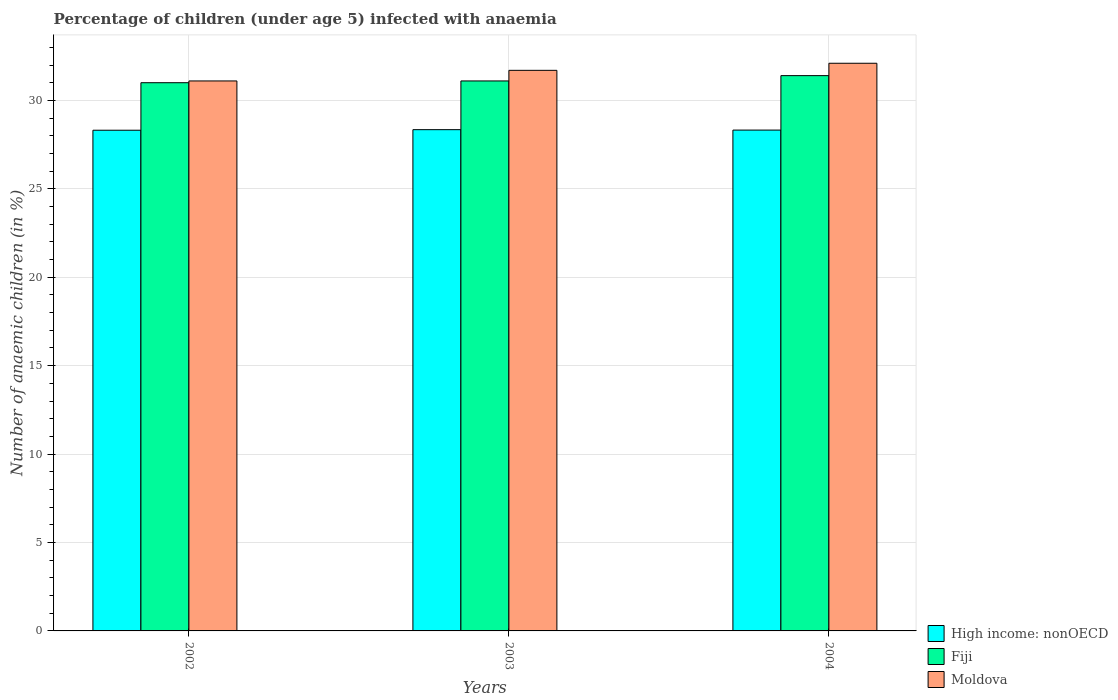How many groups of bars are there?
Make the answer very short. 3. Are the number of bars per tick equal to the number of legend labels?
Offer a terse response. Yes. Are the number of bars on each tick of the X-axis equal?
Keep it short and to the point. Yes. How many bars are there on the 3rd tick from the right?
Give a very brief answer. 3. What is the label of the 3rd group of bars from the left?
Keep it short and to the point. 2004. In how many cases, is the number of bars for a given year not equal to the number of legend labels?
Your response must be concise. 0. What is the percentage of children infected with anaemia in in High income: nonOECD in 2003?
Provide a succinct answer. 28.34. Across all years, what is the maximum percentage of children infected with anaemia in in High income: nonOECD?
Your answer should be compact. 28.34. Across all years, what is the minimum percentage of children infected with anaemia in in Moldova?
Provide a succinct answer. 31.1. In which year was the percentage of children infected with anaemia in in Moldova minimum?
Give a very brief answer. 2002. What is the total percentage of children infected with anaemia in in High income: nonOECD in the graph?
Your answer should be compact. 84.98. What is the difference between the percentage of children infected with anaemia in in High income: nonOECD in 2003 and that in 2004?
Ensure brevity in your answer.  0.02. What is the difference between the percentage of children infected with anaemia in in Fiji in 2002 and the percentage of children infected with anaemia in in Moldova in 2004?
Provide a succinct answer. -1.1. What is the average percentage of children infected with anaemia in in Moldova per year?
Provide a succinct answer. 31.63. In the year 2002, what is the difference between the percentage of children infected with anaemia in in High income: nonOECD and percentage of children infected with anaemia in in Fiji?
Your response must be concise. -2.69. What is the ratio of the percentage of children infected with anaemia in in Moldova in 2002 to that in 2003?
Offer a terse response. 0.98. Is the percentage of children infected with anaemia in in Fiji in 2002 less than that in 2003?
Offer a very short reply. Yes. Is the difference between the percentage of children infected with anaemia in in High income: nonOECD in 2002 and 2003 greater than the difference between the percentage of children infected with anaemia in in Fiji in 2002 and 2003?
Make the answer very short. Yes. What is the difference between the highest and the second highest percentage of children infected with anaemia in in Moldova?
Your answer should be compact. 0.4. What is the difference between the highest and the lowest percentage of children infected with anaemia in in High income: nonOECD?
Keep it short and to the point. 0.03. What does the 3rd bar from the left in 2004 represents?
Offer a very short reply. Moldova. What does the 1st bar from the right in 2002 represents?
Your response must be concise. Moldova. How many bars are there?
Make the answer very short. 9. Are all the bars in the graph horizontal?
Provide a short and direct response. No. How many years are there in the graph?
Your response must be concise. 3. Does the graph contain any zero values?
Provide a short and direct response. No. How are the legend labels stacked?
Ensure brevity in your answer.  Vertical. What is the title of the graph?
Your response must be concise. Percentage of children (under age 5) infected with anaemia. Does "Virgin Islands" appear as one of the legend labels in the graph?
Your answer should be compact. No. What is the label or title of the Y-axis?
Keep it short and to the point. Number of anaemic children (in %). What is the Number of anaemic children (in %) of High income: nonOECD in 2002?
Keep it short and to the point. 28.31. What is the Number of anaemic children (in %) of Fiji in 2002?
Your answer should be very brief. 31. What is the Number of anaemic children (in %) of Moldova in 2002?
Your answer should be very brief. 31.1. What is the Number of anaemic children (in %) in High income: nonOECD in 2003?
Offer a very short reply. 28.34. What is the Number of anaemic children (in %) in Fiji in 2003?
Provide a succinct answer. 31.1. What is the Number of anaemic children (in %) in Moldova in 2003?
Ensure brevity in your answer.  31.7. What is the Number of anaemic children (in %) in High income: nonOECD in 2004?
Offer a terse response. 28.32. What is the Number of anaemic children (in %) in Fiji in 2004?
Keep it short and to the point. 31.4. What is the Number of anaemic children (in %) in Moldova in 2004?
Provide a short and direct response. 32.1. Across all years, what is the maximum Number of anaemic children (in %) in High income: nonOECD?
Provide a short and direct response. 28.34. Across all years, what is the maximum Number of anaemic children (in %) in Fiji?
Ensure brevity in your answer.  31.4. Across all years, what is the maximum Number of anaemic children (in %) in Moldova?
Offer a terse response. 32.1. Across all years, what is the minimum Number of anaemic children (in %) in High income: nonOECD?
Ensure brevity in your answer.  28.31. Across all years, what is the minimum Number of anaemic children (in %) of Fiji?
Offer a very short reply. 31. Across all years, what is the minimum Number of anaemic children (in %) of Moldova?
Your response must be concise. 31.1. What is the total Number of anaemic children (in %) of High income: nonOECD in the graph?
Ensure brevity in your answer.  84.98. What is the total Number of anaemic children (in %) of Fiji in the graph?
Provide a succinct answer. 93.5. What is the total Number of anaemic children (in %) in Moldova in the graph?
Ensure brevity in your answer.  94.9. What is the difference between the Number of anaemic children (in %) of High income: nonOECD in 2002 and that in 2003?
Offer a very short reply. -0.03. What is the difference between the Number of anaemic children (in %) in Moldova in 2002 and that in 2003?
Offer a terse response. -0.6. What is the difference between the Number of anaemic children (in %) of High income: nonOECD in 2002 and that in 2004?
Offer a very short reply. -0.01. What is the difference between the Number of anaemic children (in %) in High income: nonOECD in 2003 and that in 2004?
Your response must be concise. 0.02. What is the difference between the Number of anaemic children (in %) of Fiji in 2003 and that in 2004?
Offer a very short reply. -0.3. What is the difference between the Number of anaemic children (in %) of High income: nonOECD in 2002 and the Number of anaemic children (in %) of Fiji in 2003?
Provide a short and direct response. -2.79. What is the difference between the Number of anaemic children (in %) in High income: nonOECD in 2002 and the Number of anaemic children (in %) in Moldova in 2003?
Your answer should be compact. -3.39. What is the difference between the Number of anaemic children (in %) of Fiji in 2002 and the Number of anaemic children (in %) of Moldova in 2003?
Provide a short and direct response. -0.7. What is the difference between the Number of anaemic children (in %) of High income: nonOECD in 2002 and the Number of anaemic children (in %) of Fiji in 2004?
Keep it short and to the point. -3.09. What is the difference between the Number of anaemic children (in %) in High income: nonOECD in 2002 and the Number of anaemic children (in %) in Moldova in 2004?
Your answer should be compact. -3.79. What is the difference between the Number of anaemic children (in %) in High income: nonOECD in 2003 and the Number of anaemic children (in %) in Fiji in 2004?
Make the answer very short. -3.06. What is the difference between the Number of anaemic children (in %) in High income: nonOECD in 2003 and the Number of anaemic children (in %) in Moldova in 2004?
Ensure brevity in your answer.  -3.76. What is the average Number of anaemic children (in %) of High income: nonOECD per year?
Your answer should be very brief. 28.33. What is the average Number of anaemic children (in %) of Fiji per year?
Ensure brevity in your answer.  31.17. What is the average Number of anaemic children (in %) of Moldova per year?
Keep it short and to the point. 31.63. In the year 2002, what is the difference between the Number of anaemic children (in %) in High income: nonOECD and Number of anaemic children (in %) in Fiji?
Give a very brief answer. -2.69. In the year 2002, what is the difference between the Number of anaemic children (in %) of High income: nonOECD and Number of anaemic children (in %) of Moldova?
Provide a short and direct response. -2.79. In the year 2002, what is the difference between the Number of anaemic children (in %) in Fiji and Number of anaemic children (in %) in Moldova?
Offer a terse response. -0.1. In the year 2003, what is the difference between the Number of anaemic children (in %) in High income: nonOECD and Number of anaemic children (in %) in Fiji?
Your answer should be very brief. -2.76. In the year 2003, what is the difference between the Number of anaemic children (in %) of High income: nonOECD and Number of anaemic children (in %) of Moldova?
Offer a very short reply. -3.36. In the year 2004, what is the difference between the Number of anaemic children (in %) in High income: nonOECD and Number of anaemic children (in %) in Fiji?
Your answer should be very brief. -3.08. In the year 2004, what is the difference between the Number of anaemic children (in %) in High income: nonOECD and Number of anaemic children (in %) in Moldova?
Your response must be concise. -3.78. In the year 2004, what is the difference between the Number of anaemic children (in %) in Fiji and Number of anaemic children (in %) in Moldova?
Your answer should be very brief. -0.7. What is the ratio of the Number of anaemic children (in %) of Fiji in 2002 to that in 2003?
Offer a terse response. 1. What is the ratio of the Number of anaemic children (in %) in Moldova in 2002 to that in 2003?
Provide a succinct answer. 0.98. What is the ratio of the Number of anaemic children (in %) in High income: nonOECD in 2002 to that in 2004?
Your answer should be very brief. 1. What is the ratio of the Number of anaemic children (in %) in Fiji in 2002 to that in 2004?
Offer a terse response. 0.99. What is the ratio of the Number of anaemic children (in %) in Moldova in 2002 to that in 2004?
Your answer should be very brief. 0.97. What is the ratio of the Number of anaemic children (in %) of Moldova in 2003 to that in 2004?
Your answer should be very brief. 0.99. What is the difference between the highest and the second highest Number of anaemic children (in %) of High income: nonOECD?
Ensure brevity in your answer.  0.02. What is the difference between the highest and the second highest Number of anaemic children (in %) in Fiji?
Provide a short and direct response. 0.3. What is the difference between the highest and the lowest Number of anaemic children (in %) in High income: nonOECD?
Keep it short and to the point. 0.03. What is the difference between the highest and the lowest Number of anaemic children (in %) in Fiji?
Offer a terse response. 0.4. 